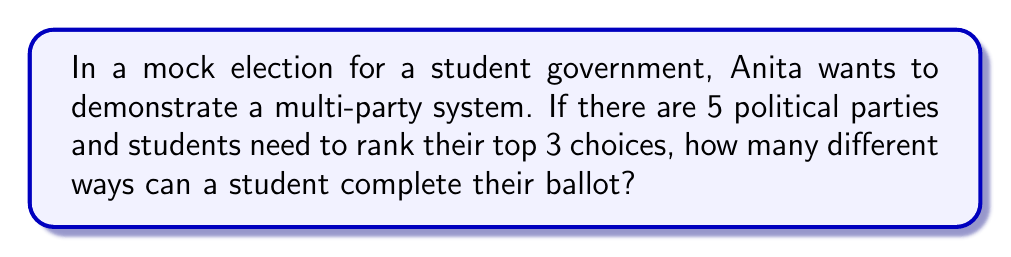What is the answer to this math problem? Let's approach this step-by-step:

1) This is a permutation problem, as the order of selection matters.

2) We are selecting 3 parties out of 5, where repetition is not allowed (a party can't be selected more than once).

3) The formula for permutations without repetition is:

   $$P(n,r) = \frac{n!}{(n-r)!}$$

   Where $n$ is the total number of items to choose from, and $r$ is the number of items being chosen.

4) In this case, $n = 5$ (total number of parties) and $r = 3$ (number of rankings on the ballot).

5) Plugging these numbers into our formula:

   $$P(5,3) = \frac{5!}{(5-3)!} = \frac{5!}{2!}$$

6) Expanding this:
   
   $$\frac{5 \times 4 \times 3 \times 2!}{2!} = 5 \times 4 \times 3 = 60$$

Therefore, there are 60 different ways a student can rank their top 3 choices out of 5 parties.
Answer: 60 